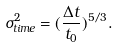<formula> <loc_0><loc_0><loc_500><loc_500>\sigma _ { t i m e } ^ { 2 } = ( \frac { \Delta t } { t _ { 0 } } ) ^ { 5 / 3 } .</formula> 